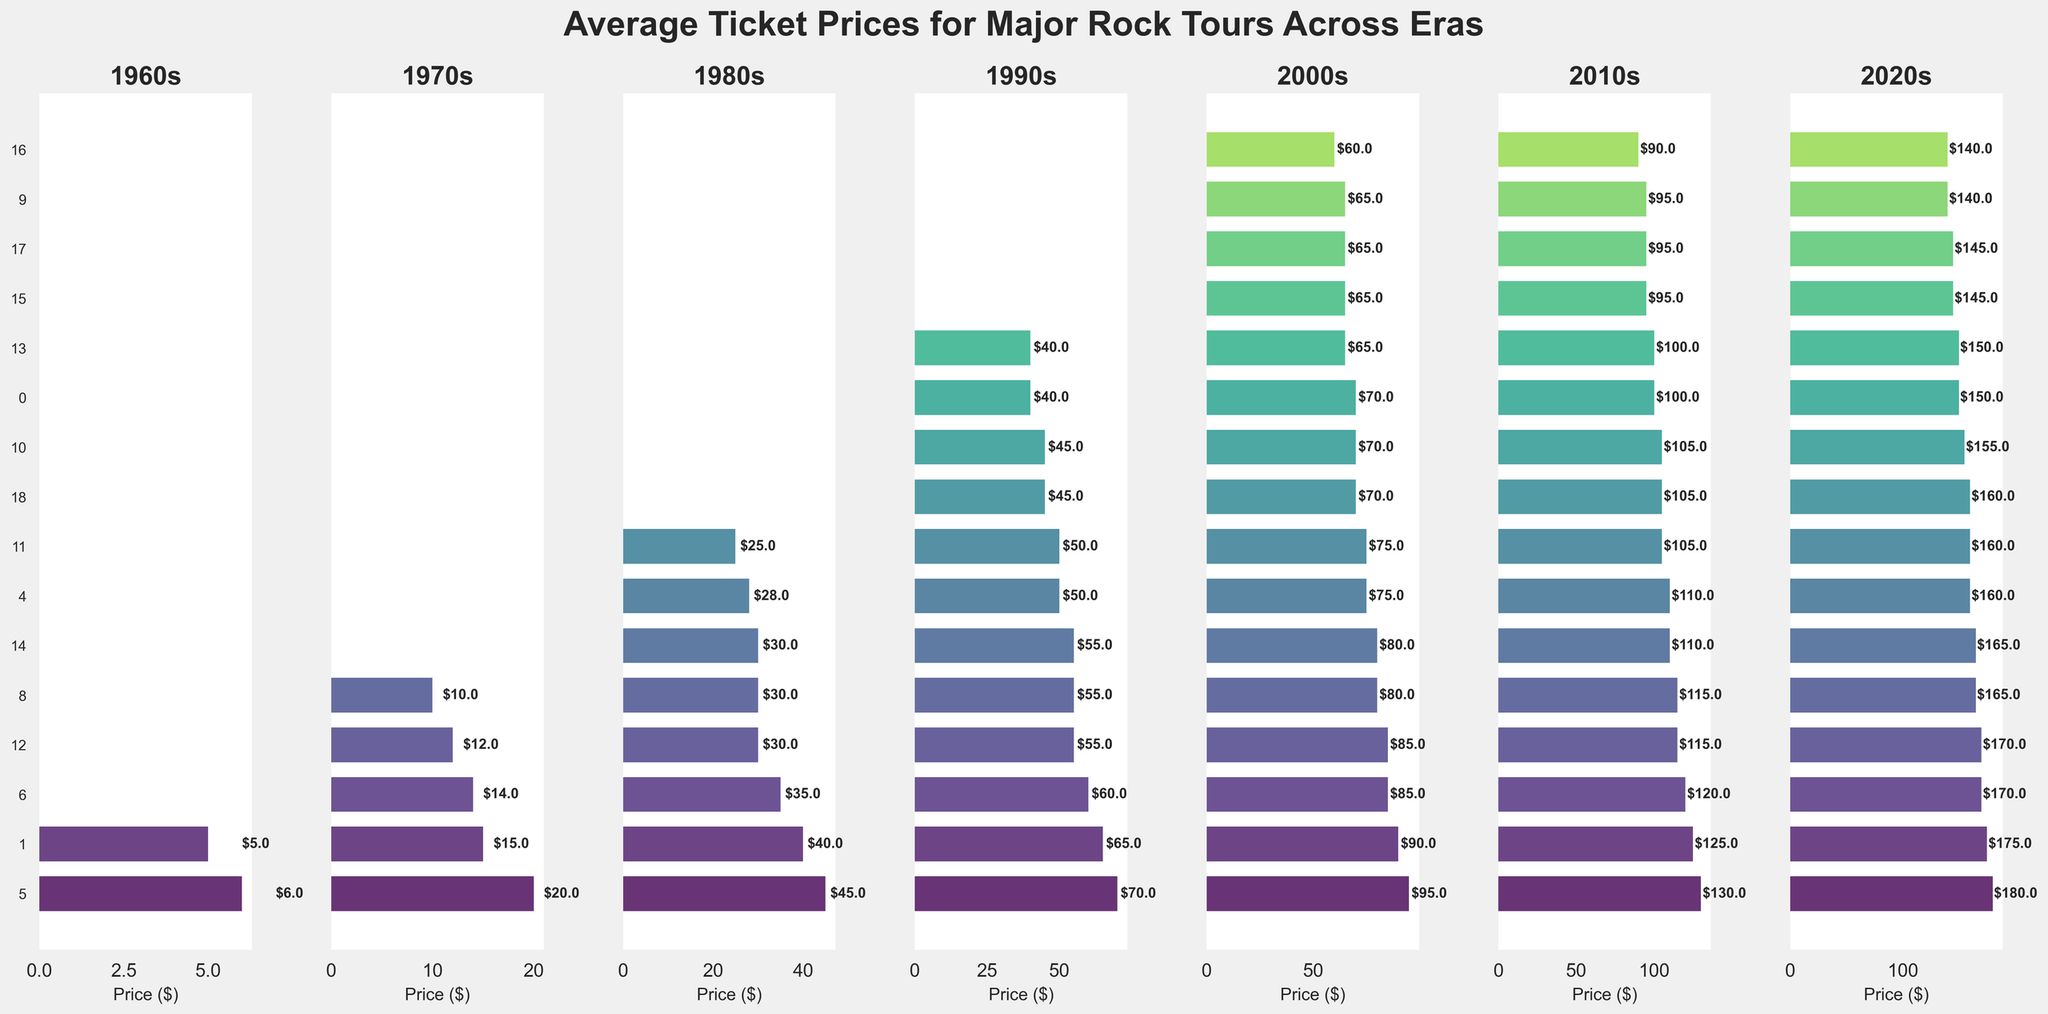Which band had the highest ticket price in the 2020s? Look at the subplot for the 2020s and identify the bar with the greatest length. The label next to the longest bar is the band with the highest ticket price.
Answer: Rolling Stones Which era had the highest average ticket price increase compared to the 1960s? Calculate the increase in average ticket price from the 1960s to each era: 1970s ($10 - $5 = $5), 1980s ($25 - $5 = $20), 1990s ($50 - $5 = $45), 2000s ($75 - $5 = $70), 2010s ($100 - $5 = $95), 2020s ($150 - $5 = $145). The era with the largest increase is the 2020s.
Answer: 2020s How does the ticket price of Radiohead in the 2010s compare to that of Foo Fighters in the same era? Find the bars for Radiohead and Foo Fighters in the 2010s subplot. Compare their lengths to determine which is higher.
Answer: Radiohead has a higher ticket price Which bands appeared consistently from the 1970s to the 2020s? Check for bands that have ticket prices listed in each subplot from the 1970s through the 2020s. The bands are Rolling Stones and Bruce Springsteen.
Answer: Rolling Stones and Bruce Springsteen What is the percentage increase in ticket price for Metallica from the 1980s to the 2000s? Calculate the percentage increase using the formula: ((New Price - Old Price) / Old Price) * 100. For Metallica: ((85 - 30) / 30) * 100 = 183.33%.
Answer: 183.33% Which era shows the largest difference between the average ticket price and the highest individual band ticket price? Calculate the difference for each era by subtracting the average ticket price from the highest individual band ticket price. Identify the era with the largest difference: 1960s ($6 - $5 = $1), 1970s ($20 - $10 = $10), 1980s ($40 - $25 = $15), 1990s ($70 - $50 = $20), 2000s ($125 - $75 = $50), 2010s ($130 - $100 = $30), 2020s ($180 - $150 = $30). The largest difference is in the 2000s.
Answer: 2000s Which band has the second highest ticket price in the 1990s? Look at the subplot for the 1990s, find the second longest bar, and identify the band's label next to it.
Answer: Metallica How many bands had ticket prices above the average in the 1980s? Calculate the number of bands with ticket prices greater than $25 in the 1980s subplot. The bands are Bruce Springsteen, Guns N' Roses, Nirvana, Metallica, and Queen.
Answer: 5 What percentage of bands had ticket prices listed in the 1970s? Count the number of bands with ticket prices in the 1970s (5 bands). Divide this by the total number of bands in all subplots and multiply by 100: (5 / 15) * 100 ≈ 33.33%.
Answer: 33.33% 